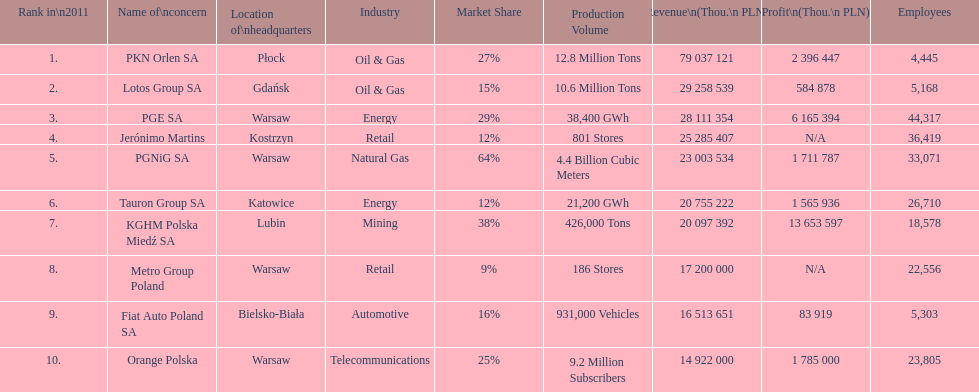Which business had the greatest earnings? PKN Orlen SA. 